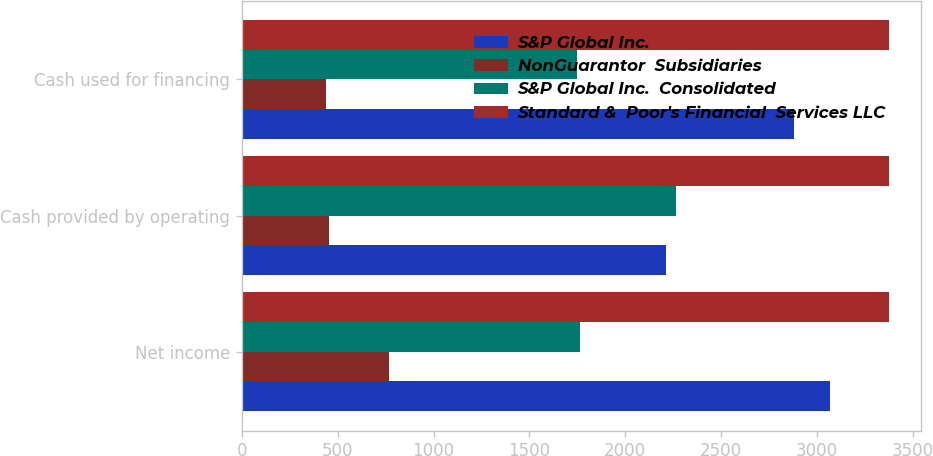Convert chart to OTSL. <chart><loc_0><loc_0><loc_500><loc_500><stacked_bar_chart><ecel><fcel>Net income<fcel>Cash provided by operating<fcel>Cash used for financing<nl><fcel>S&P Global Inc.<fcel>3069<fcel>2215<fcel>2881<nl><fcel>NonGuarantor  Subsidiaries<fcel>767<fcel>456<fcel>441<nl><fcel>S&P Global Inc.  Consolidated<fcel>1766<fcel>2263<fcel>1748<nl><fcel>Standard &  Poor's Financial  Services LLC<fcel>3374<fcel>3374<fcel>3374<nl></chart> 